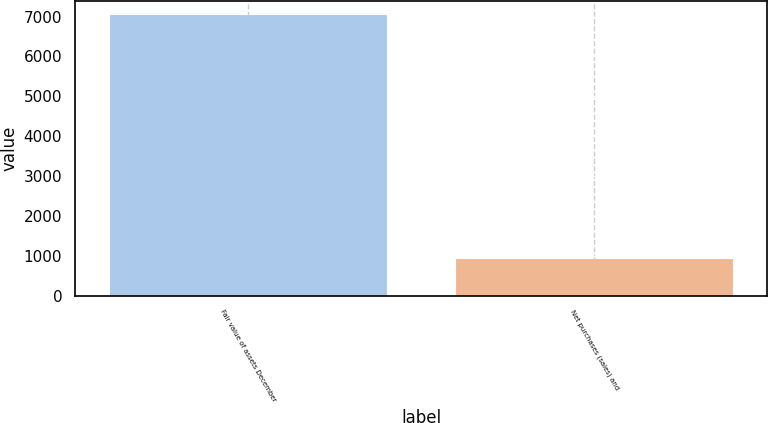<chart> <loc_0><loc_0><loc_500><loc_500><bar_chart><fcel>Fair value of assets December<fcel>Net purchases (sales) and<nl><fcel>7039<fcel>911<nl></chart> 